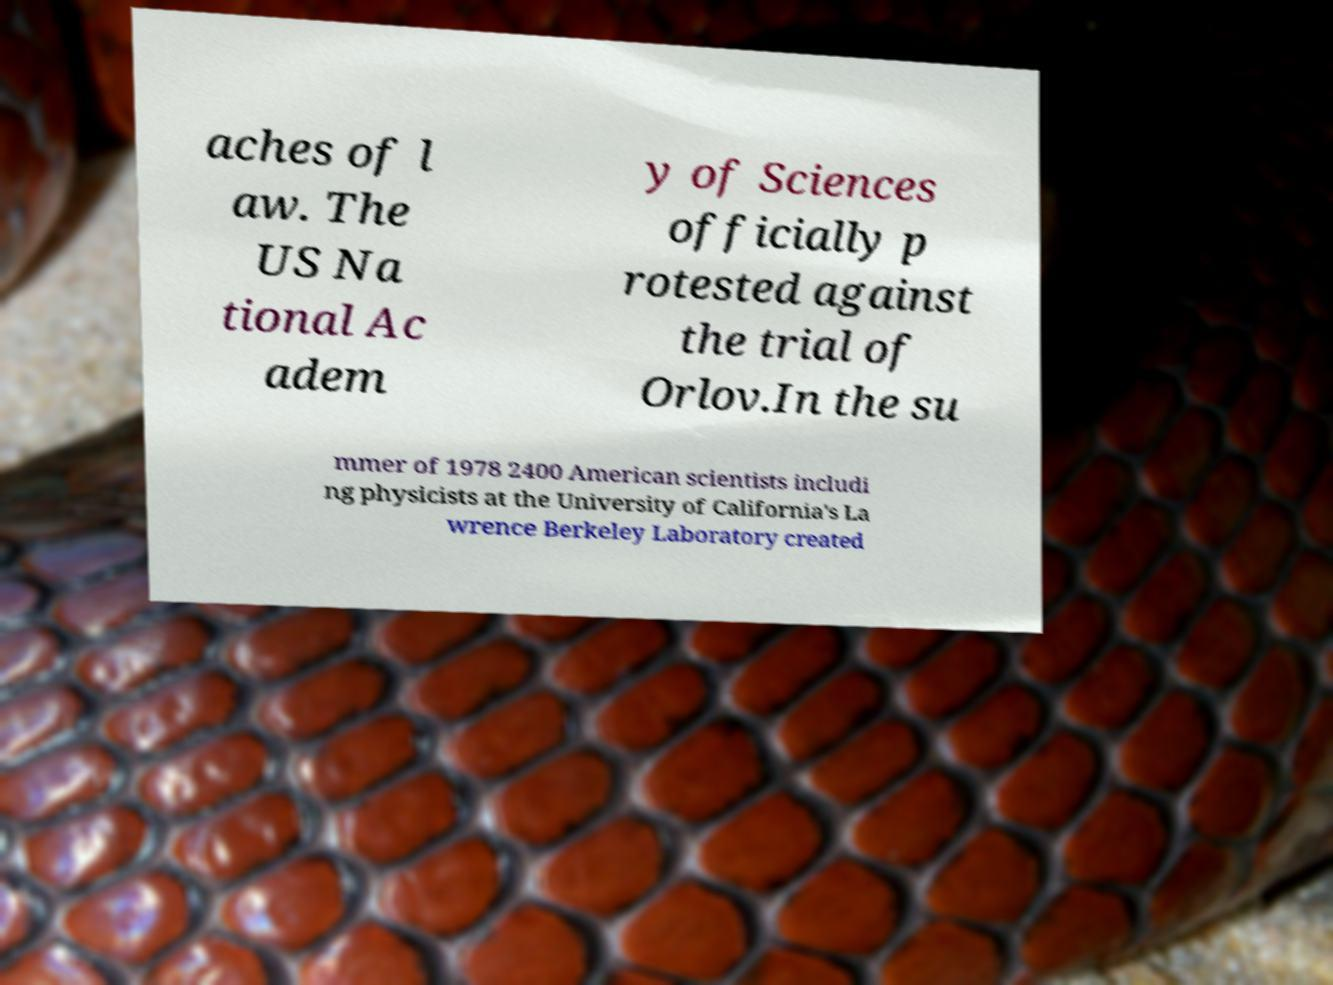Could you assist in decoding the text presented in this image and type it out clearly? aches of l aw. The US Na tional Ac adem y of Sciences officially p rotested against the trial of Orlov.In the su mmer of 1978 2400 American scientists includi ng physicists at the University of California's La wrence Berkeley Laboratory created 